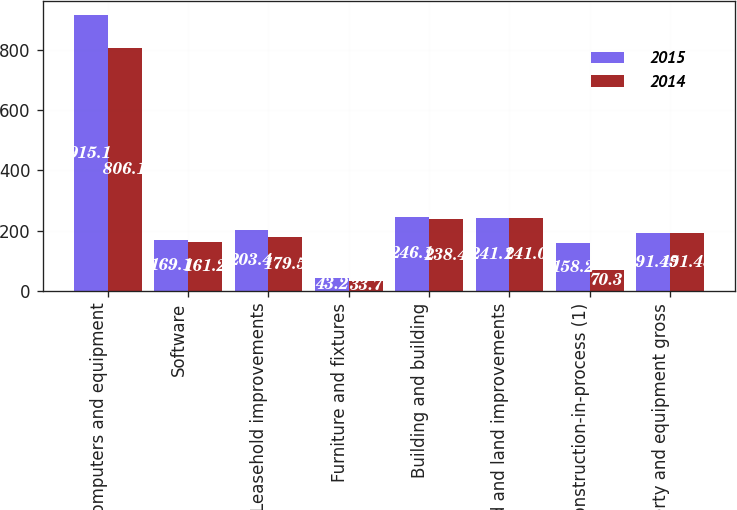Convert chart to OTSL. <chart><loc_0><loc_0><loc_500><loc_500><stacked_bar_chart><ecel><fcel>Computers and equipment<fcel>Software<fcel>Leasehold improvements<fcel>Furniture and fixtures<fcel>Building and building<fcel>Land and land improvements<fcel>Construction-in-process (1)<fcel>Property and equipment gross<nl><fcel>2015<fcel>915.1<fcel>169.1<fcel>203.4<fcel>43.2<fcel>246.1<fcel>241.1<fcel>158.2<fcel>191.45<nl><fcel>2014<fcel>806.1<fcel>161.2<fcel>179.5<fcel>33.7<fcel>238.4<fcel>241<fcel>70.3<fcel>191.45<nl></chart> 